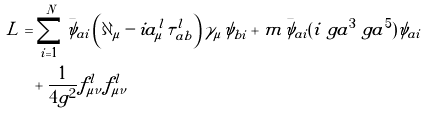Convert formula to latex. <formula><loc_0><loc_0><loc_500><loc_500>L & = \sum _ { i = 1 } ^ { N } \bar { \psi } _ { a i } \left ( \partial _ { \mu } - i a _ { \mu } ^ { l } \tau ^ { l } _ { a b } \right ) \gamma _ { \mu } \psi _ { b i } + m \bar { \psi } _ { a i } ( i \ g a ^ { 3 } \ g a ^ { 5 } ) { \psi } _ { a i } \\ & \ \ + \frac { 1 } { 4 g ^ { 2 } } f ^ { l } _ { \mu \nu } f ^ { l } _ { \mu \nu }</formula> 